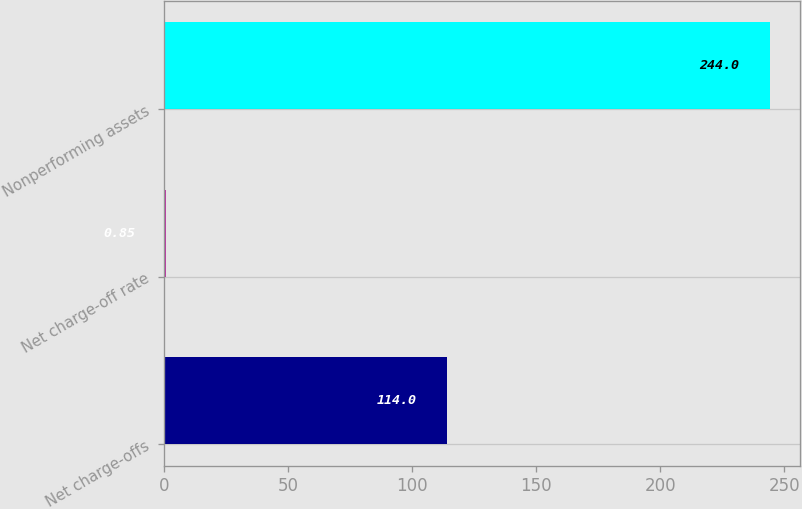<chart> <loc_0><loc_0><loc_500><loc_500><bar_chart><fcel>Net charge-offs<fcel>Net charge-off rate<fcel>Nonperforming assets<nl><fcel>114<fcel>0.85<fcel>244<nl></chart> 